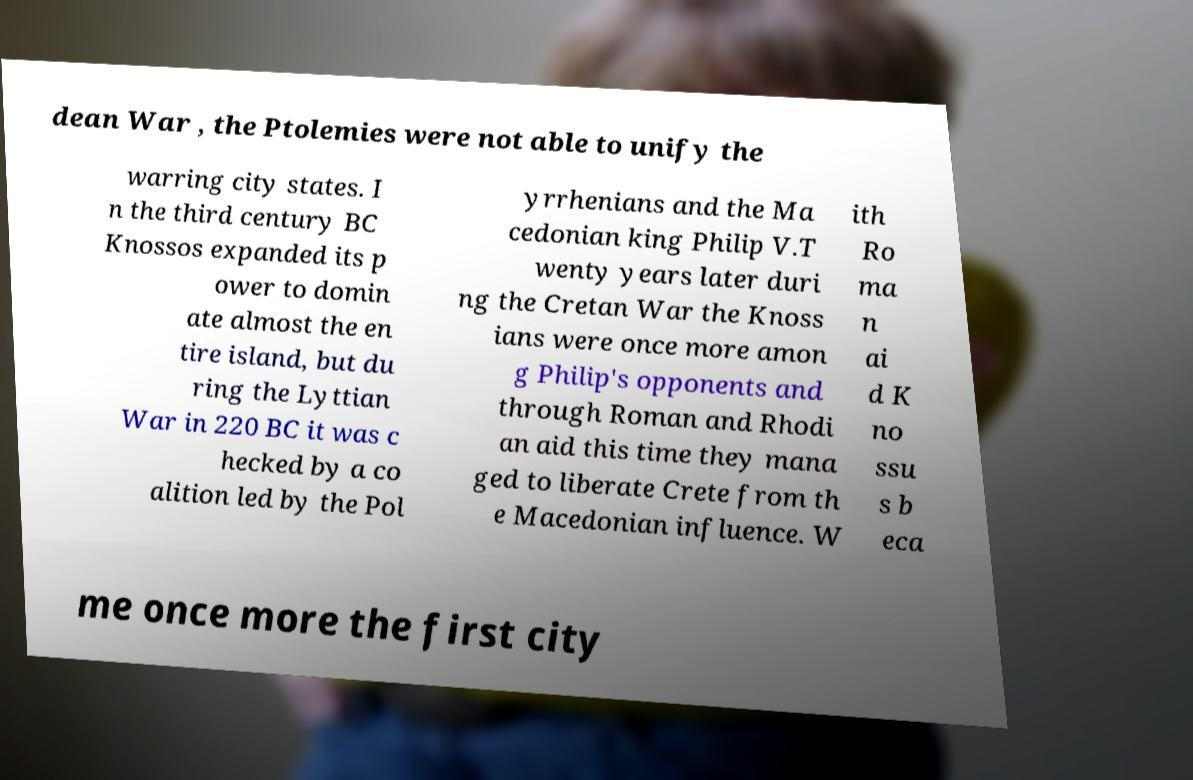Could you extract and type out the text from this image? dean War , the Ptolemies were not able to unify the warring city states. I n the third century BC Knossos expanded its p ower to domin ate almost the en tire island, but du ring the Lyttian War in 220 BC it was c hecked by a co alition led by the Pol yrrhenians and the Ma cedonian king Philip V.T wenty years later duri ng the Cretan War the Knoss ians were once more amon g Philip's opponents and through Roman and Rhodi an aid this time they mana ged to liberate Crete from th e Macedonian influence. W ith Ro ma n ai d K no ssu s b eca me once more the first city 